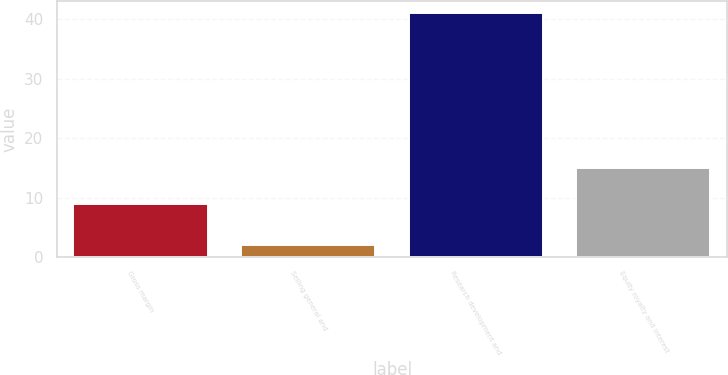Convert chart to OTSL. <chart><loc_0><loc_0><loc_500><loc_500><bar_chart><fcel>Gross margin<fcel>Selling general and<fcel>Research development and<fcel>Equity royalty and interest<nl><fcel>9<fcel>2<fcel>41<fcel>15<nl></chart> 